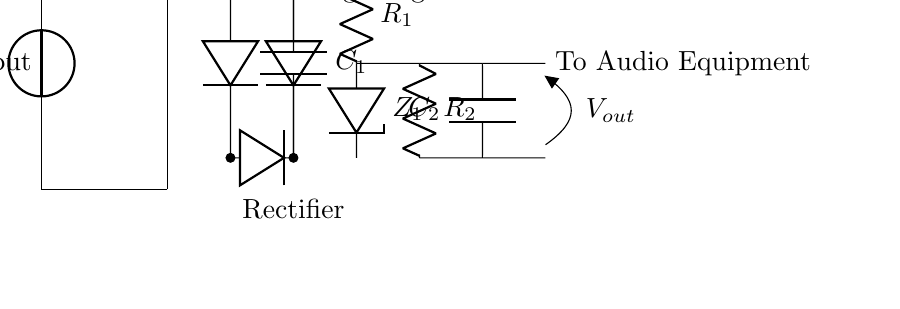What is the input voltage of the circuit? The input voltage is denoted as V-in, which indicates the voltage supplied to the circuit from an external source.
Answer: V-in What type of components are used in the voltage regulation part? The voltage regulation section includes a resistor labeled R-1 and a Zener diode labeled Z-1, which work together to maintain a steady output voltage.
Answer: Resistor and Zener diode How many diodes are in the rectifier? The rectifier is made up of four diodes, which are configured to convert AC voltage to DC voltage by allowing current to flow in one direction.
Answer: Four What does the capacitor C-1 do in the circuit? Capacitor C-1 smooths the rectified voltage by filtering out fluctuations, thereby providing a more stable DC voltage to the voltage regulator.
Answer: Smooths voltage What is the purpose of the transformer in this circuit? The transformer steps down the voltage from the AC source to a level suitable for the rectifier and the subsequent components, ensuring they operate within safe limits.
Answer: Steps down voltage What is the output label indicating in the circuit? The output label V-out indicates the regulated DC voltage that will be supplied to the audio equipment, and it is the voltage after regulation.
Answer: V-out What does the second capacitor C-2 achieve in this configuration? Capacitor C-2 further stabilizes the output voltage by filtering additional noise or ripple, ensuring clean power delivery to the audio equipment.
Answer: Further stabilizes output 